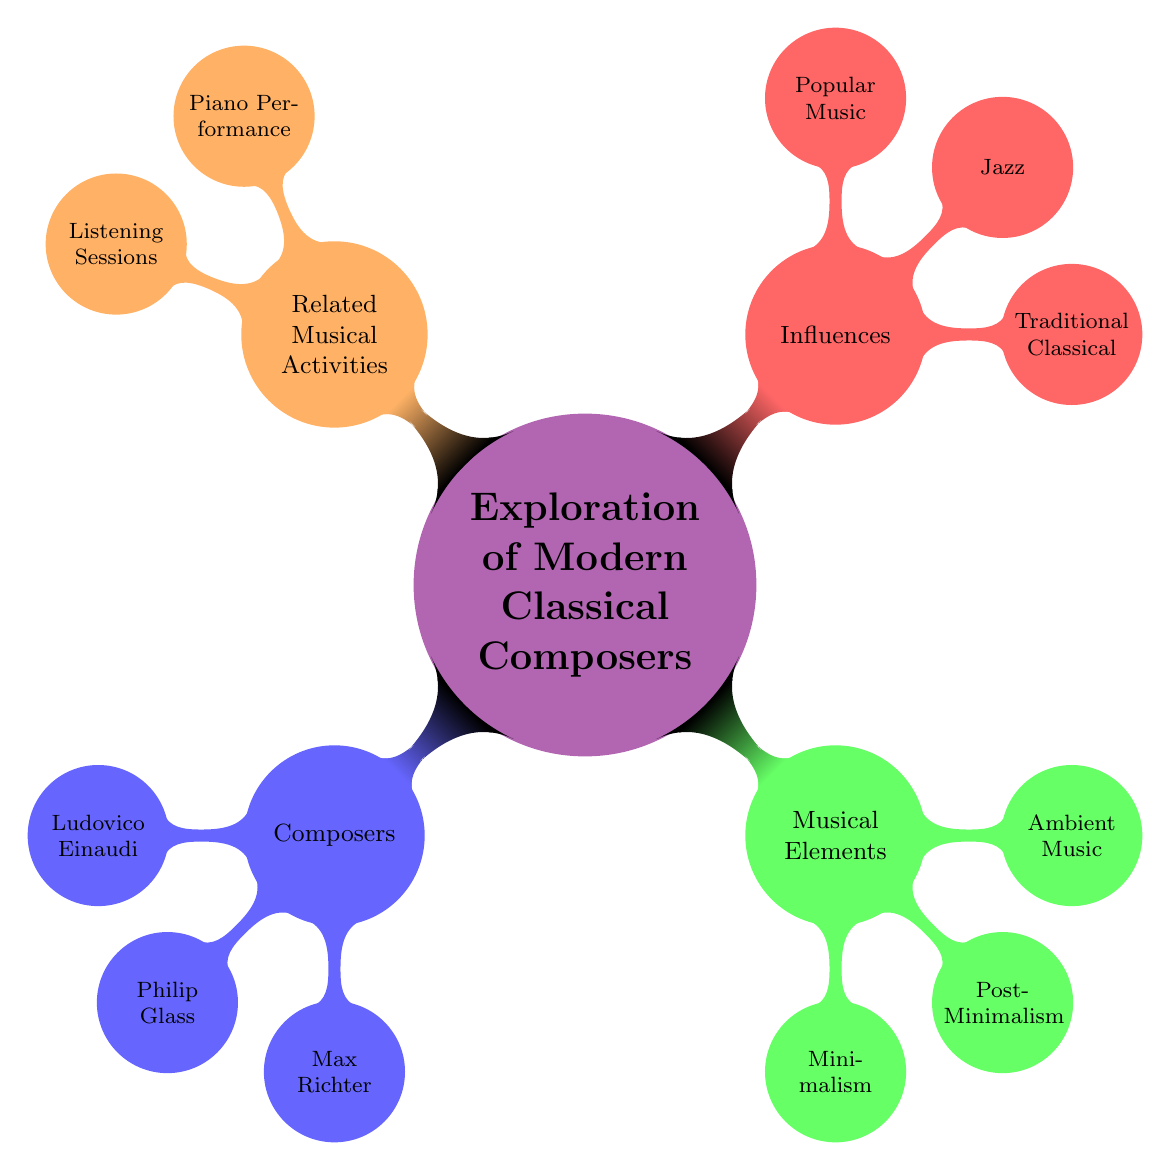What are the names of the composers listed? The diagram includes three composers under the "Composers" node: Ludovico Einaudi, Philip Glass, and Max Richter.
Answer: Ludovico Einaudi, Philip Glass, Max Richter How many musical elements are identified? There are three musical elements under the "Musical Elements" node: Minimalism, Post-Minimalism, and Ambient Music.
Answer: 3 Which composer is associated with Ambient Music? The "Ambient Music" node specifically states that Ludovico Einaudi is the key composer for this genre, as noted under "Musical Elements."
Answer: Ludovico Einaudi What types of influences are mentioned? The diagram outlines three categories of influence on modern classical composers: Traditional Classical, Jazz, and Popular Music.
Answer: Traditional Classical, Jazz, Popular Music Who are the key composers associated with Minimalism? The "Minimalism" node lists Philip Glass and Steve Reich as key composers, indicating their importance in this musical style.
Answer: Philip Glass, Steve Reich Which composer has notable works titled "Recomposed (Vivaldi's Four Seasons)"? The diagram shows this particular work associated with Max Richter under the "Notable Works" section.
Answer: Max Richter How many related musical activities are shown? The diagram presents two categories under "Related Musical Activities": Piano Performance and Listening Sessions, totaling two activities.
Answer: 2 What is the style of Max Richter? The diagram states that Max Richter's style is categorized as Post-Minimalist and Neo-Classical.
Answer: Post-Minimalist, Neo-Classical What is the definition of Minimalism according to the diagram? The "Minimalism" node describes it as the repetition of simple musical motifs, explaining its foundational characteristic in this genre.
Answer: Repetition of simple musical motifs Which notable work is associated with Ludovico Einaudi? Under the "Notable Works" for Ludovico Einaudi, "Nuvole Bianche" and "Una Mattina" are cited, marking his significant contributions to music.
Answer: Nuvole Bianche, Una Mattina 